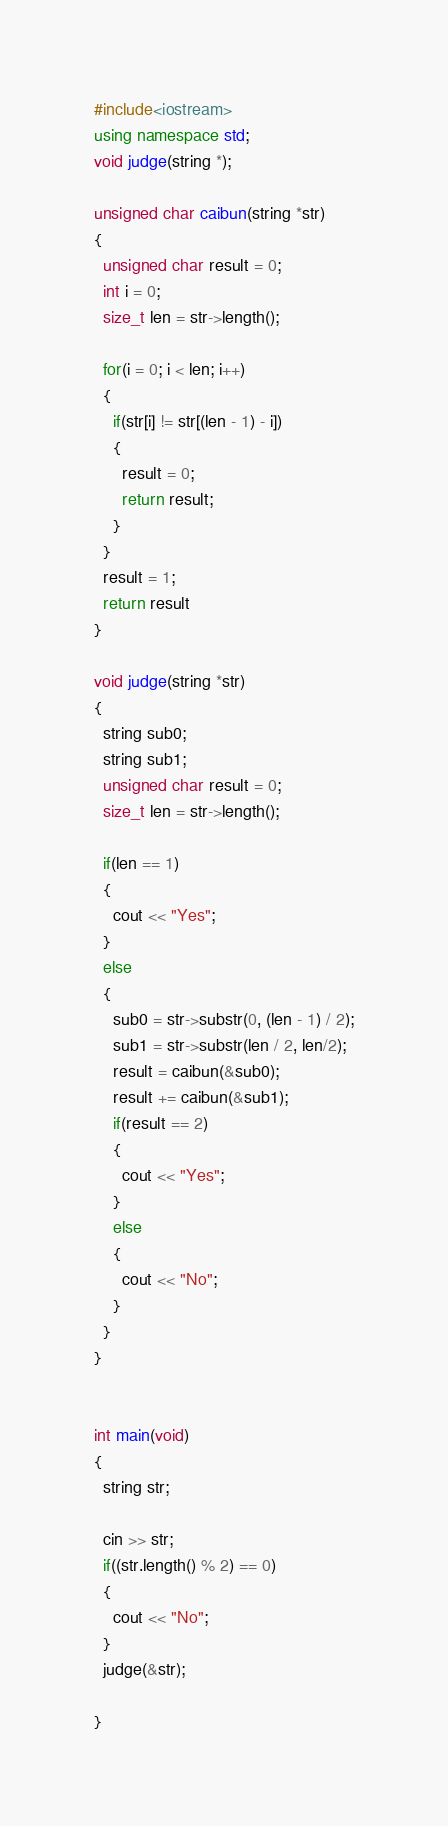<code> <loc_0><loc_0><loc_500><loc_500><_C++_>#include<iostream>
using namespace std;
void judge(string *);

unsigned char caibun(string *str)
{
  unsigned char result = 0;
  int i = 0;
  size_t len = str->length();
  
  for(i = 0; i < len; i++)
  {
    if(str[i] != str[(len - 1) - i])
    {
      result = 0;
      return result;
    }
  }
  result = 1;
  return result
}

void judge(string *str)
{
  string sub0;
  string sub1;
  unsigned char result = 0;
  size_t len = str->length();

  if(len == 1)
  {
    cout << "Yes";
  }
  else
  {
    sub0 = str->substr(0, (len - 1) / 2);
    sub1 = str->substr(len / 2, len/2);
    result = caibun(&sub0);
    result += caibun(&sub1);
    if(result == 2)
    {
      cout << "Yes";
    }
    else
    {
      cout << "No";
    }
  }
}


int main(void)
{
  string str;
  
  cin >> str;
  if((str.length() % 2) == 0)
  {
    cout << "No";
  }
  judge(&str);
 
}</code> 